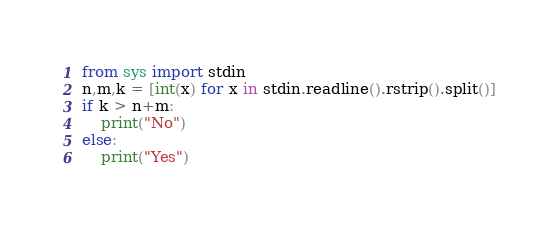<code> <loc_0><loc_0><loc_500><loc_500><_Python_>from sys import stdin
n,m,k = [int(x) for x in stdin.readline().rstrip().split()]
if k > n+m:
    print("No")
else:
    print("Yes")</code> 